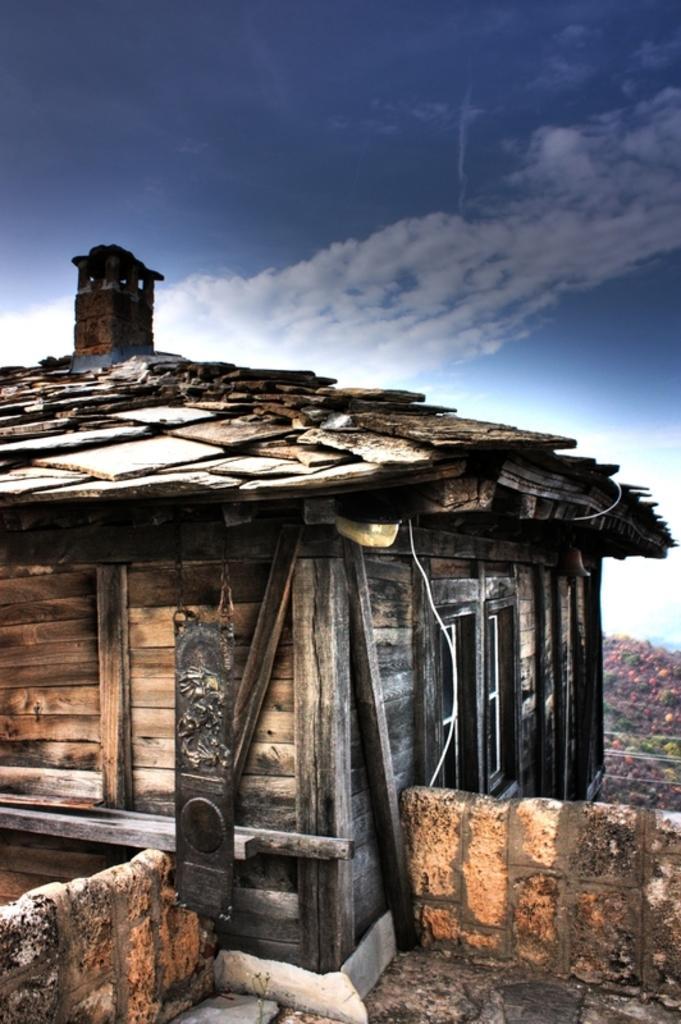How would you summarize this image in a sentence or two? In this image we can see a wooden house, a wall, there is a mountain, also we can see the sky. 